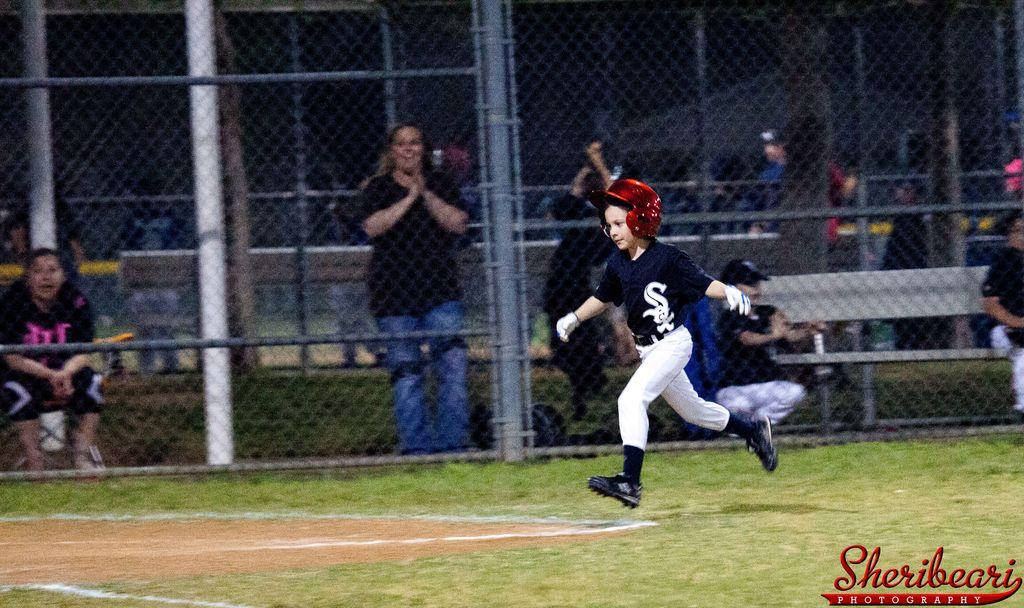Who is the main subject in the image? There is a boy in the image. What is the boy wearing on his head? The boy is wearing a helmet. What can be seen beneath the boy's feet? The ground is visible in the image. What type of barrier is present in the image? There is a fence in the image. Can you describe the people behind the fence? There are people visible behind the fence. What type of seating is present in the image? A bench is present in the image. What type of writing instrument is the boy using in the image? There is no writing instrument visible in the image; the boy is wearing a helmet. What type of explosive device is present in the image? There is no explosive device present in the image; it features a boy wearing a helmet and other details. 